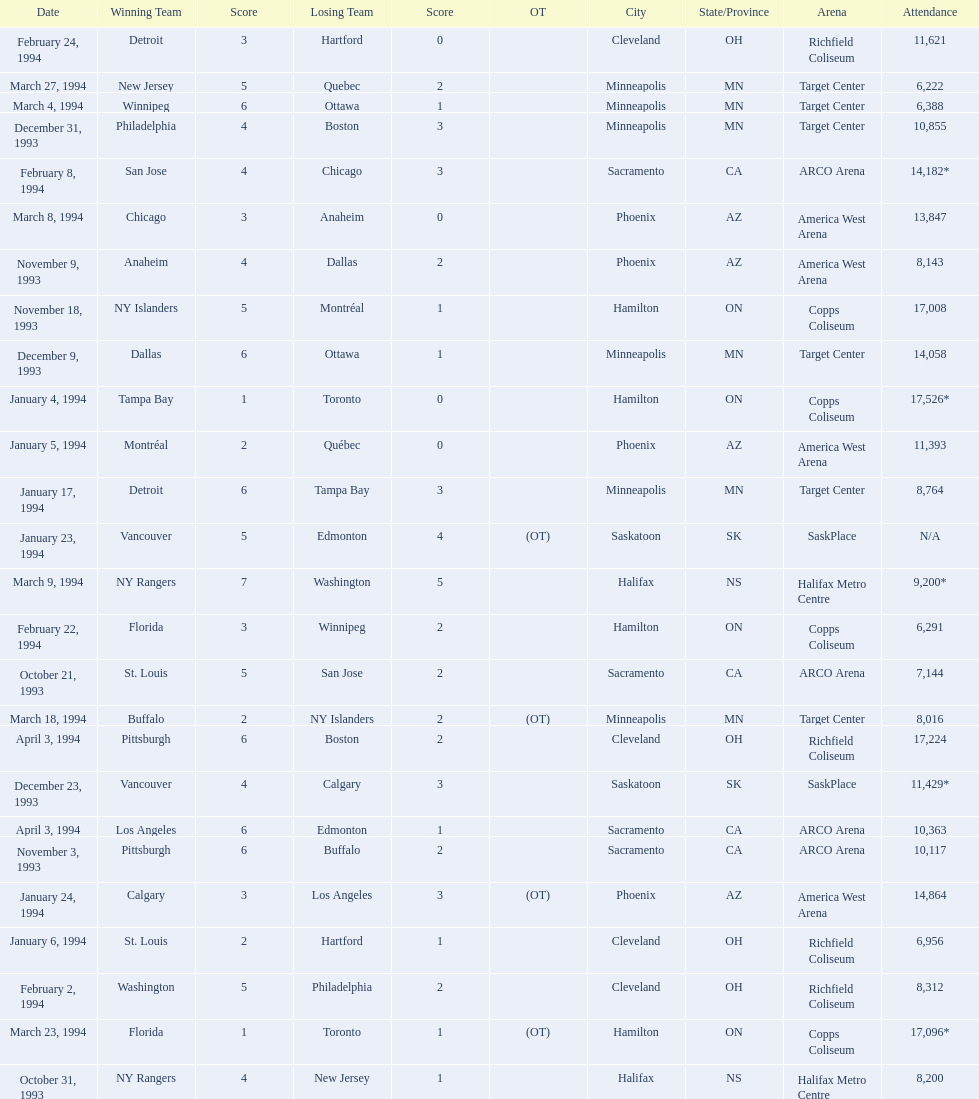Which was the highest attendance for a game? 17,526*. What was the date of the game with an attendance of 17,526? January 4, 1994. 